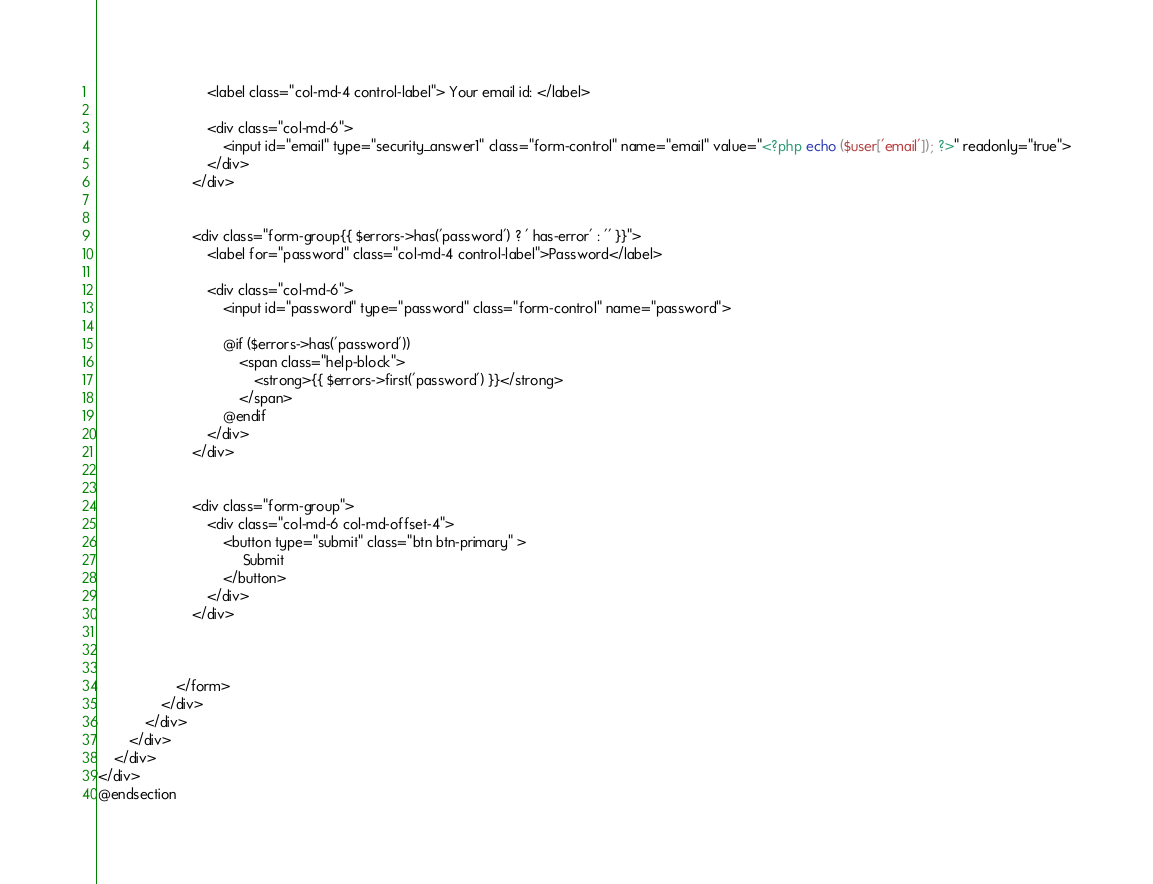<code> <loc_0><loc_0><loc_500><loc_500><_PHP_>                            <label class="col-md-4 control-label"> Your email id: </label>

                            <div class="col-md-6">
                                <input id="email" type="security_answer1" class="form-control" name="email" value="<?php echo ($user['email']); ?>" readonly="true">
                            </div>
                        </div>


                        <div class="form-group{{ $errors->has('password') ? ' has-error' : '' }}">
                            <label for="password" class="col-md-4 control-label">Password</label>

                            <div class="col-md-6">
                                <input id="password" type="password" class="form-control" name="password">

                                @if ($errors->has('password'))
                                    <span class="help-block">
                                        <strong>{{ $errors->first('password') }}</strong>
                                    </span>
                                @endif
                            </div>
                        </div>


                        <div class="form-group">
                            <div class="col-md-6 col-md-offset-4">
                                <button type="submit" class="btn btn-primary" >
                                     Submit
                                </button>
                            </div>
                        </div>



                    </form>
                </div>
            </div>
        </div>
    </div>
</div>
@endsection
</code> 